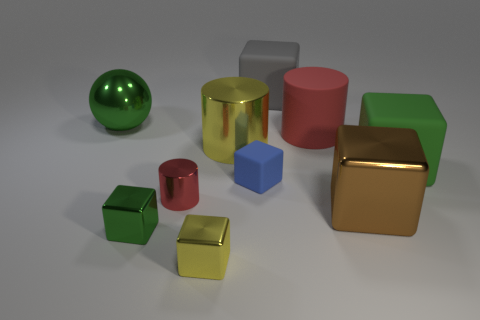There is a metallic thing on the left side of the green metal thing that is in front of the green block that is behind the small green metallic cube; what is its shape?
Your answer should be very brief. Sphere. What shape is the green matte thing that is the same size as the red rubber thing?
Provide a short and direct response. Cube. There is a object that is behind the large green object that is on the left side of the matte cylinder; how many large cubes are in front of it?
Your response must be concise. 2. Is the number of small red things that are behind the big yellow metallic thing greater than the number of tiny yellow objects on the right side of the brown metal thing?
Provide a succinct answer. No. What number of blue matte things have the same shape as the large red matte thing?
Your answer should be compact. 0. How many things are either big objects to the right of the tiny green metal object or large metallic cylinders left of the tiny blue rubber object?
Offer a very short reply. 5. There is a large green thing that is on the right side of the red cylinder left of the tiny thing right of the small yellow metal cube; what is it made of?
Keep it short and to the point. Rubber. Is the color of the big matte object that is behind the big green ball the same as the big shiny cylinder?
Your answer should be very brief. No. There is a green object that is behind the small metallic cylinder and left of the tiny red object; what material is it?
Your answer should be compact. Metal. Is there a blue metallic ball that has the same size as the brown object?
Your answer should be compact. No. 